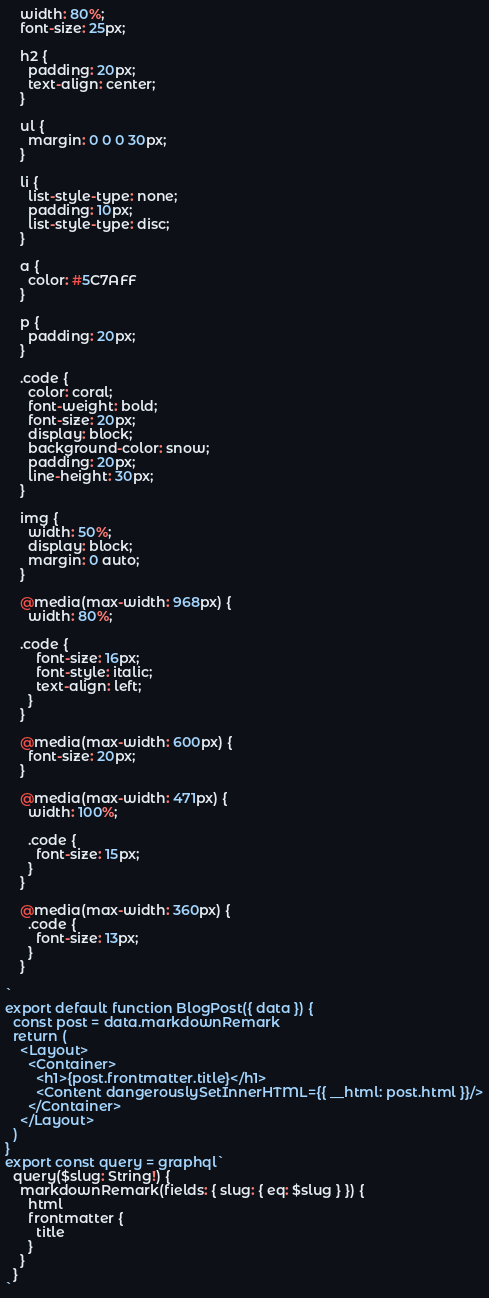Convert code to text. <code><loc_0><loc_0><loc_500><loc_500><_JavaScript_>    width: 80%;
    font-size: 25px;

    h2 {
      padding: 20px;
      text-align: center;
    }

    ul {
      margin: 0 0 0 30px;
    }

    li {
      list-style-type: none;
      padding: 10px;
      list-style-type: disc;
    }

    a {
      color: #5C7AFF
    }

    p {
      padding: 20px;
    }

    .code {
      color: coral;
      font-weight: bold;
      font-size: 20px;
      display: block;
      background-color: snow;
      padding: 20px;
      line-height: 30px; 
    }

    img {
      width: 50%;
      display: block;
      margin: 0 auto;
    }

    @media(max-width: 968px) {
      width: 80%;
      
    .code {
        font-size: 16px;
        font-style: italic;
        text-align: left;
      }
    }

    @media(max-width: 600px) {
      font-size: 20px;
    }

    @media(max-width: 471px) {
      width: 100%;

      .code {
        font-size: 15px;
      }
    }
    
    @media(max-width: 360px) {
      .code {
        font-size: 13px;
      }
    }

`
export default function BlogPost({ data }) {
  const post = data.markdownRemark
  return (
    <Layout>
      <Container>
        <h1>{post.frontmatter.title}</h1>
        <Content dangerouslySetInnerHTML={{ __html: post.html }}/>
      </Container>
    </Layout>
  )
}
export const query = graphql`
  query($slug: String!) {
    markdownRemark(fields: { slug: { eq: $slug } }) {
      html
      frontmatter {
        title
      }
    }
  }
`
</code> 